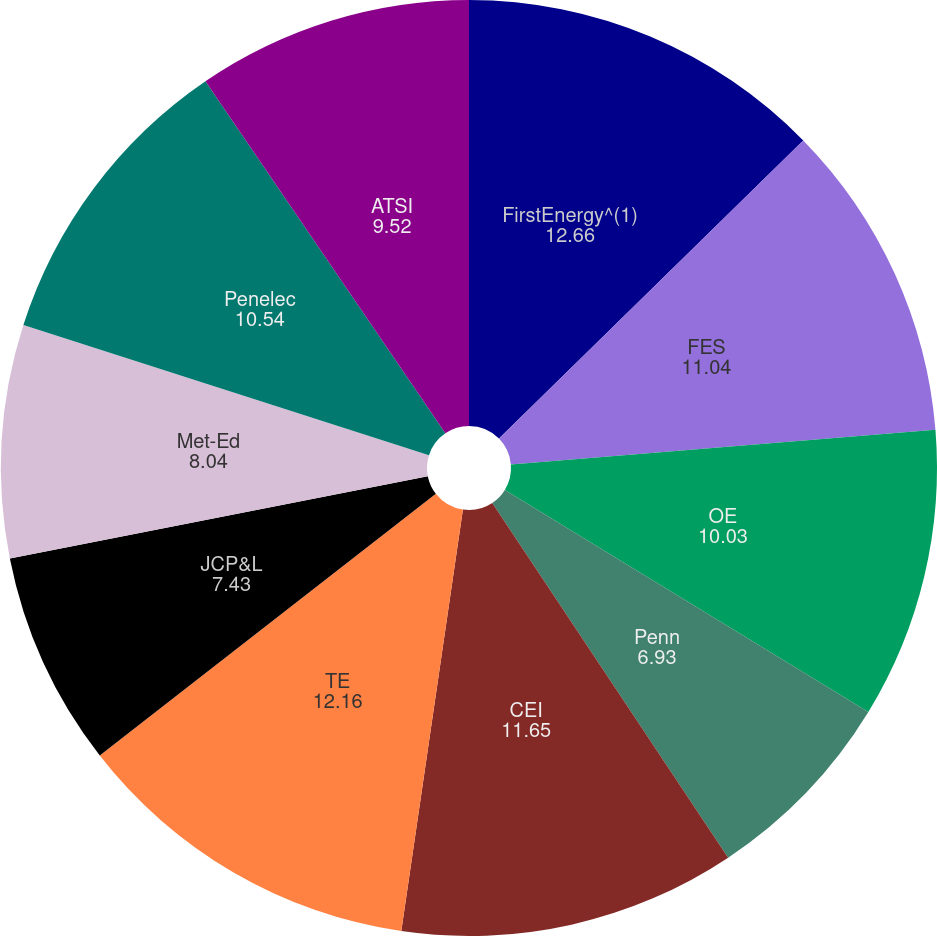<chart> <loc_0><loc_0><loc_500><loc_500><pie_chart><fcel>FirstEnergy^(1)<fcel>FES<fcel>OE<fcel>Penn<fcel>CEI<fcel>TE<fcel>JCP&L<fcel>Met-Ed<fcel>Penelec<fcel>ATSI<nl><fcel>12.66%<fcel>11.04%<fcel>10.03%<fcel>6.93%<fcel>11.65%<fcel>12.16%<fcel>7.43%<fcel>8.04%<fcel>10.54%<fcel>9.52%<nl></chart> 